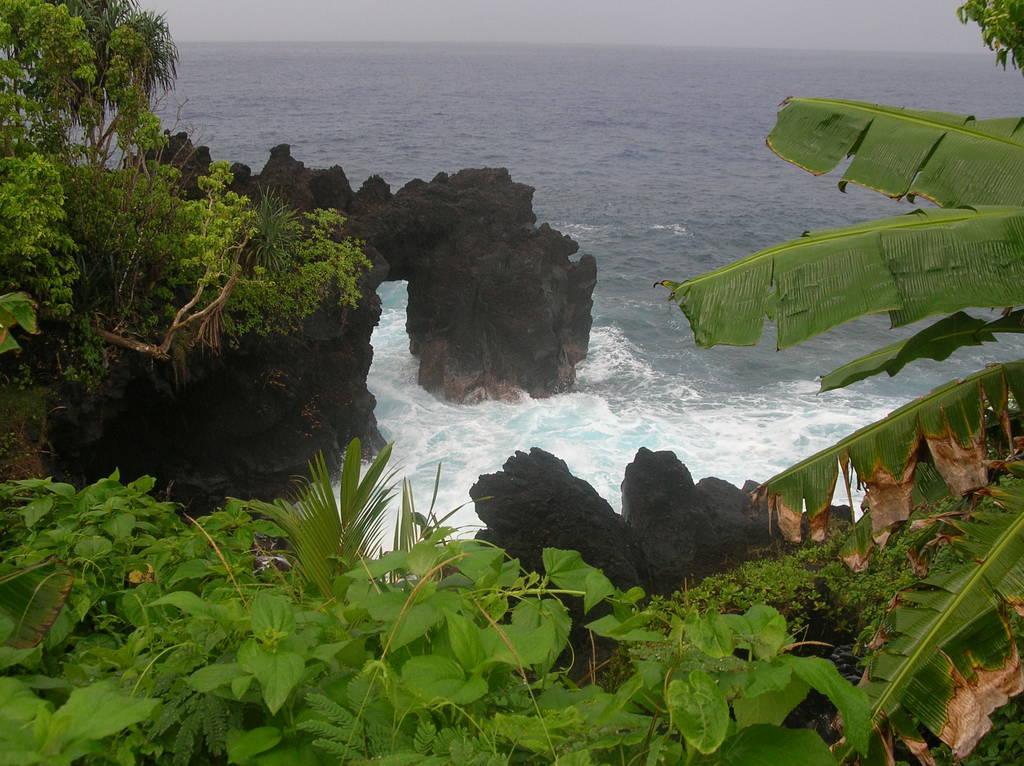How would you summarize this image in a sentence or two? In this image I can see a ocean and I can see racks and I can see planets visible. 